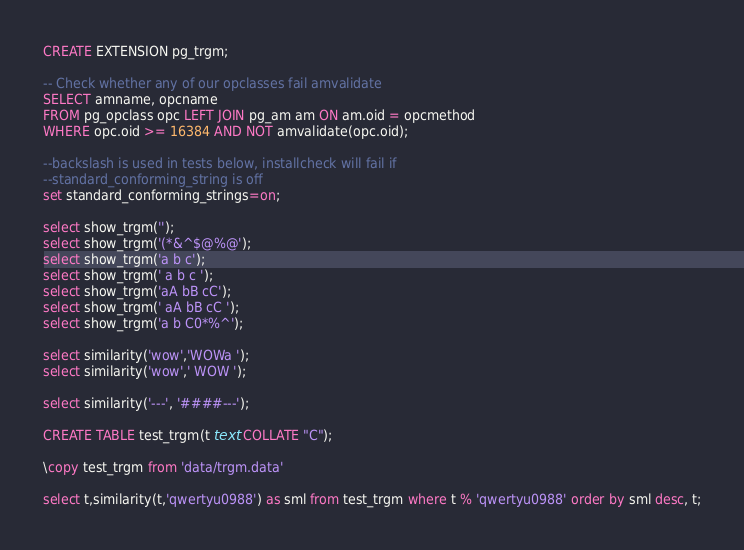<code> <loc_0><loc_0><loc_500><loc_500><_SQL_>CREATE EXTENSION pg_trgm;

-- Check whether any of our opclasses fail amvalidate
SELECT amname, opcname
FROM pg_opclass opc LEFT JOIN pg_am am ON am.oid = opcmethod
WHERE opc.oid >= 16384 AND NOT amvalidate(opc.oid);

--backslash is used in tests below, installcheck will fail if
--standard_conforming_string is off
set standard_conforming_strings=on;

select show_trgm('');
select show_trgm('(*&^$@%@');
select show_trgm('a b c');
select show_trgm(' a b c ');
select show_trgm('aA bB cC');
select show_trgm(' aA bB cC ');
select show_trgm('a b C0*%^');

select similarity('wow','WOWa ');
select similarity('wow',' WOW ');

select similarity('---', '####---');

CREATE TABLE test_trgm(t text COLLATE "C");

\copy test_trgm from 'data/trgm.data'

select t,similarity(t,'qwertyu0988') as sml from test_trgm where t % 'qwertyu0988' order by sml desc, t;</code> 